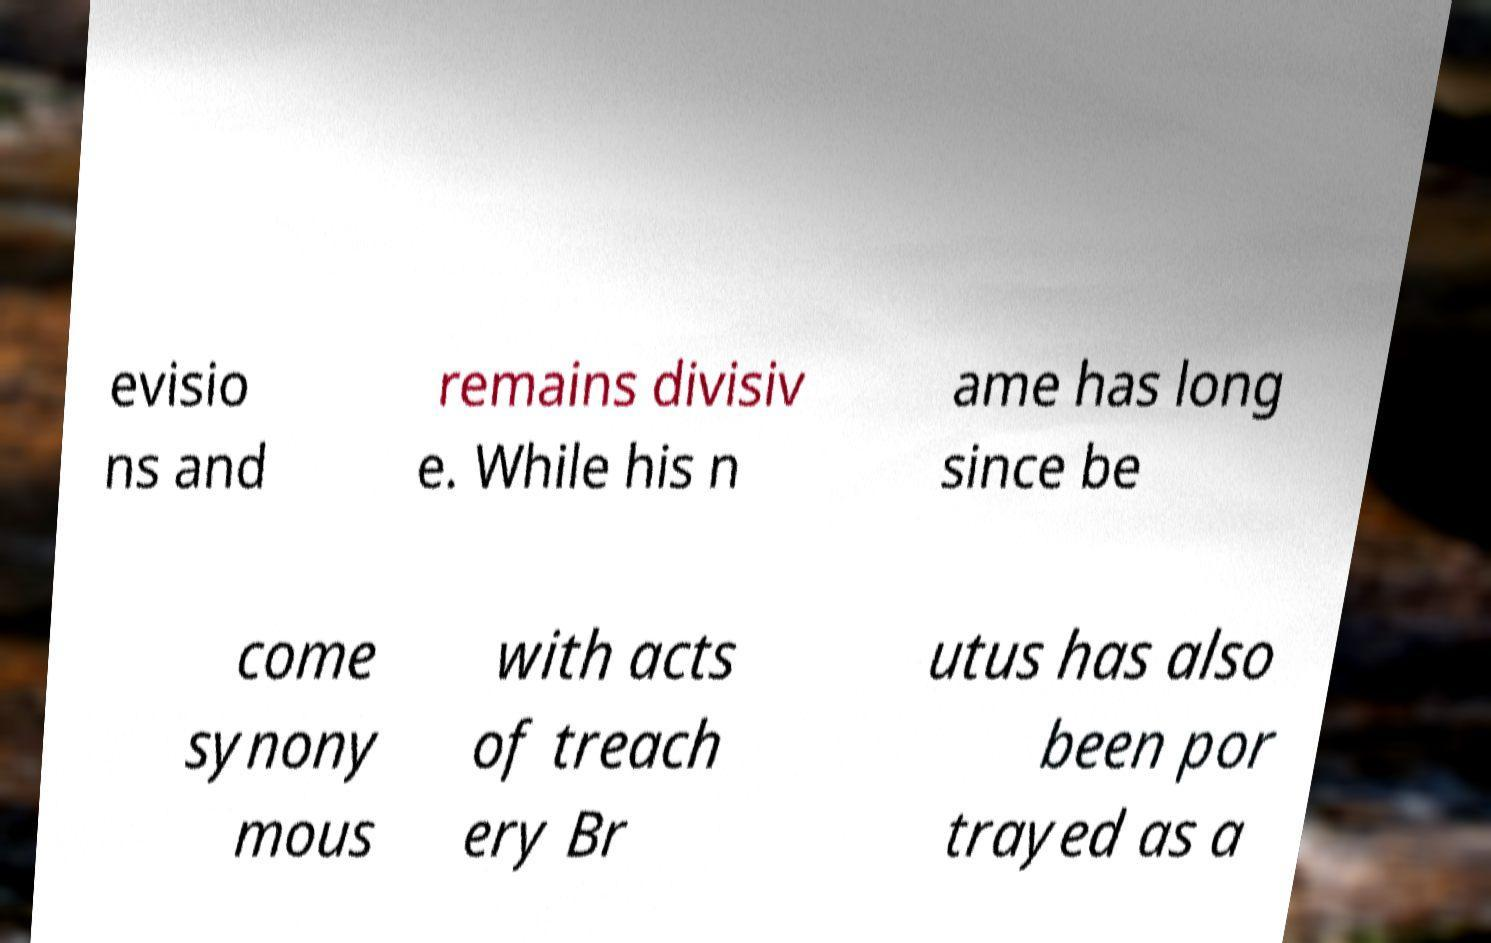There's text embedded in this image that I need extracted. Can you transcribe it verbatim? evisio ns and remains divisiv e. While his n ame has long since be come synony mous with acts of treach ery Br utus has also been por trayed as a 